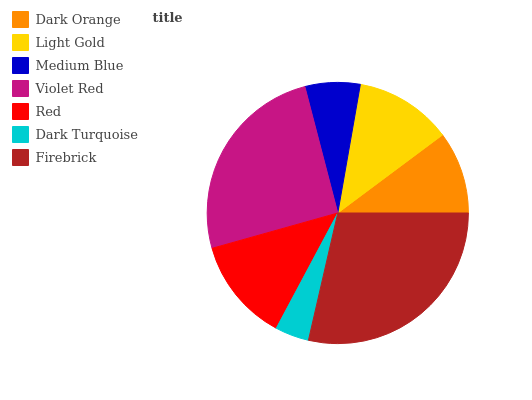Is Dark Turquoise the minimum?
Answer yes or no. Yes. Is Firebrick the maximum?
Answer yes or no. Yes. Is Light Gold the minimum?
Answer yes or no. No. Is Light Gold the maximum?
Answer yes or no. No. Is Light Gold greater than Dark Orange?
Answer yes or no. Yes. Is Dark Orange less than Light Gold?
Answer yes or no. Yes. Is Dark Orange greater than Light Gold?
Answer yes or no. No. Is Light Gold less than Dark Orange?
Answer yes or no. No. Is Light Gold the high median?
Answer yes or no. Yes. Is Light Gold the low median?
Answer yes or no. Yes. Is Dark Orange the high median?
Answer yes or no. No. Is Medium Blue the low median?
Answer yes or no. No. 